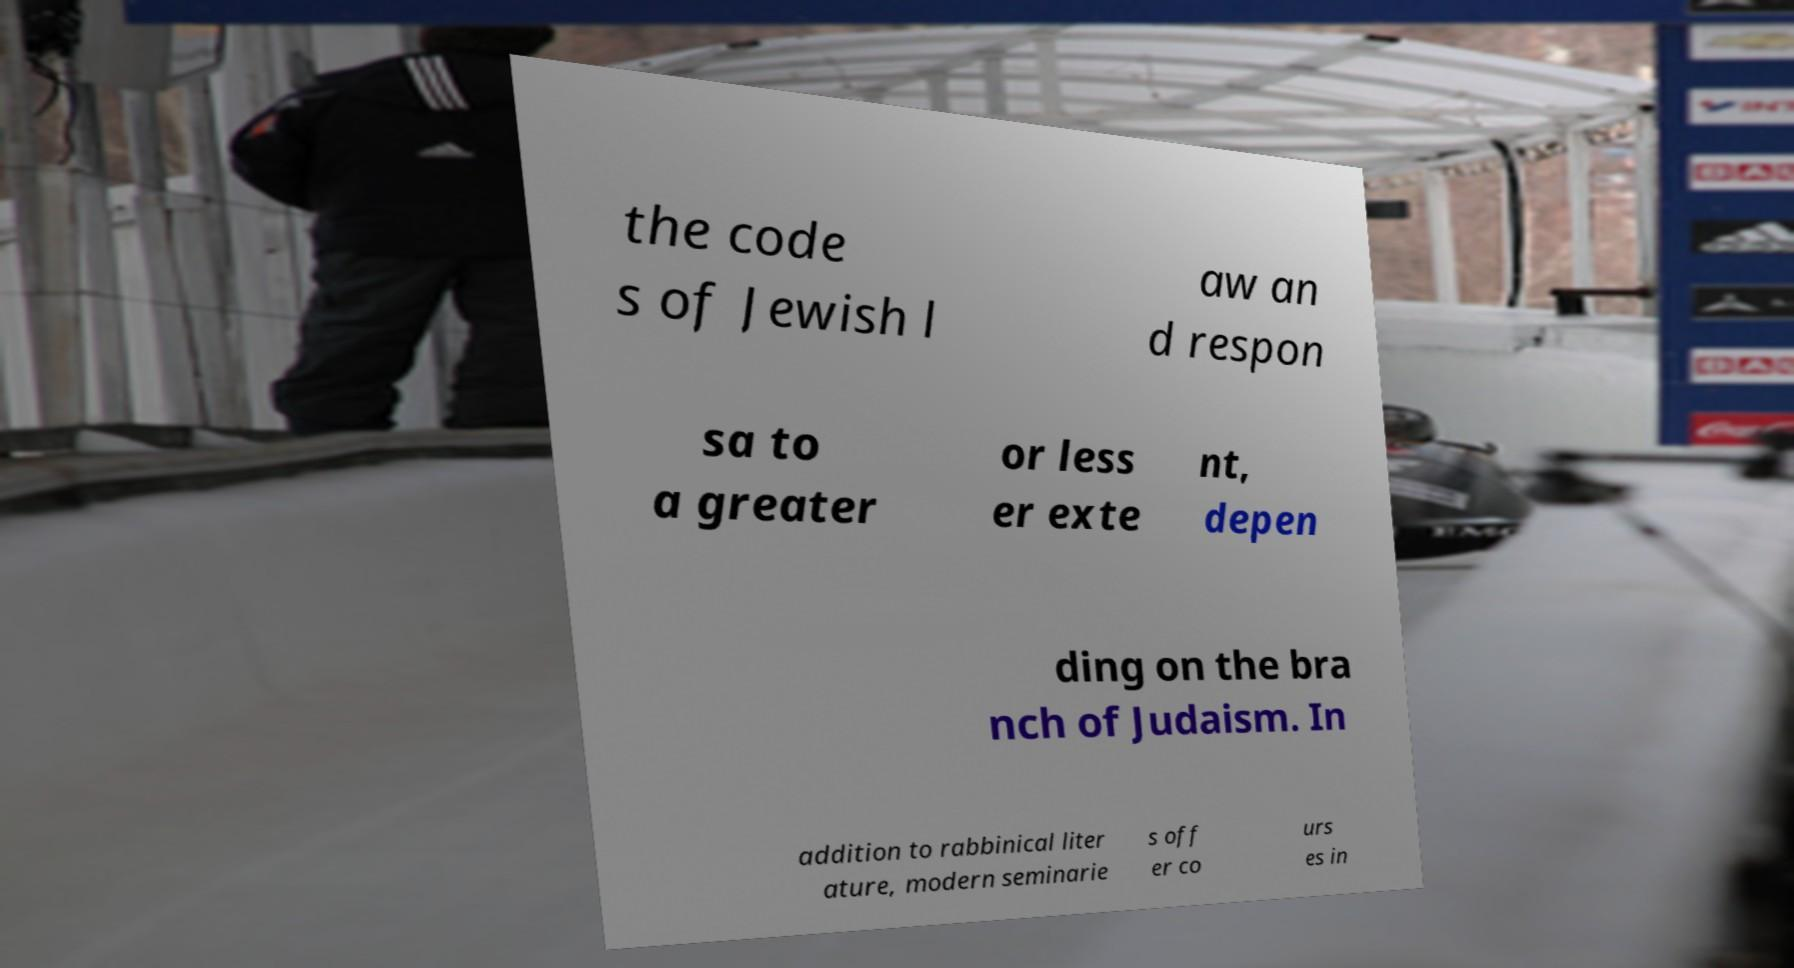Can you read and provide the text displayed in the image?This photo seems to have some interesting text. Can you extract and type it out for me? the code s of Jewish l aw an d respon sa to a greater or less er exte nt, depen ding on the bra nch of Judaism. In addition to rabbinical liter ature, modern seminarie s off er co urs es in 